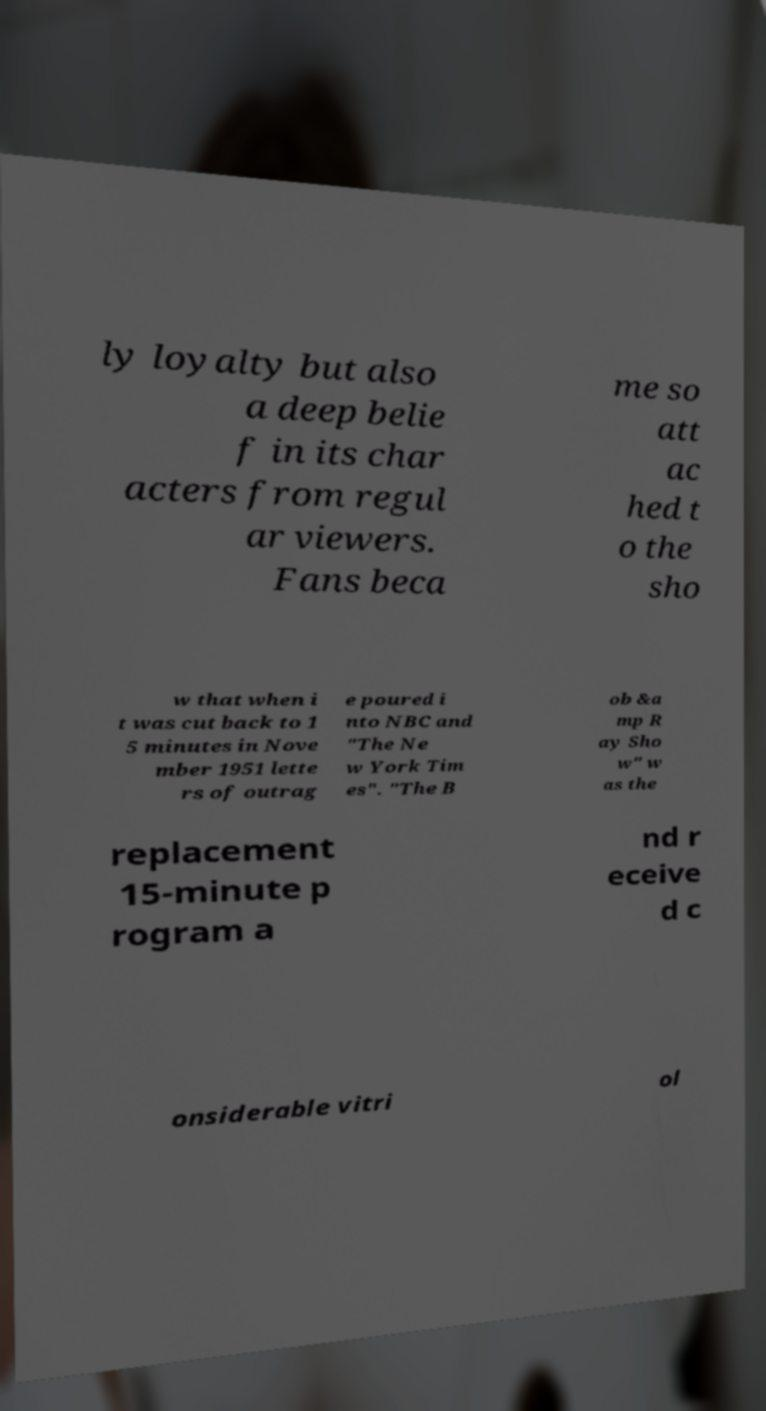Please read and relay the text visible in this image. What does it say? ly loyalty but also a deep belie f in its char acters from regul ar viewers. Fans beca me so att ac hed t o the sho w that when i t was cut back to 1 5 minutes in Nove mber 1951 lette rs of outrag e poured i nto NBC and "The Ne w York Tim es". "The B ob &a mp R ay Sho w" w as the replacement 15-minute p rogram a nd r eceive d c onsiderable vitri ol 